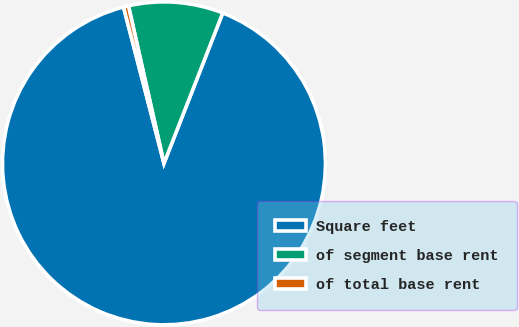Convert chart. <chart><loc_0><loc_0><loc_500><loc_500><pie_chart><fcel>Square feet<fcel>of segment base rent<fcel>of total base rent<nl><fcel>90.04%<fcel>9.46%<fcel>0.5%<nl></chart> 